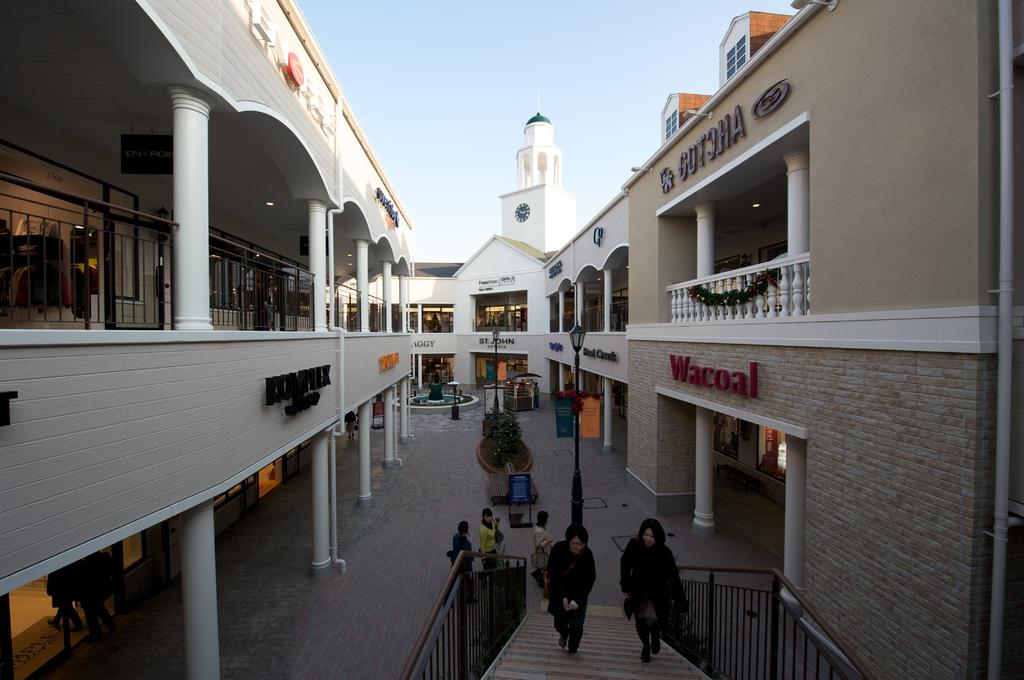What type of structures can be seen in the image? There are electric poles with lights and buildings in the image. What is present on the ground in the image? There are objects on the ground in the image. Are there any people visible in the image? Yes, there are people visible in the image. What can be seen in the background of the image? The sky is visible in the background of the image. Where is the scarecrow located in the image? There is no scarecrow present in the image. What type of underwear is the person wearing in the image? The image does not show any people wearing underwear, so it cannot be determined from the image. 